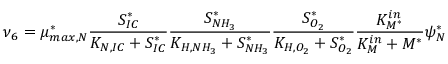Convert formula to latex. <formula><loc_0><loc_0><loc_500><loc_500>\nu _ { 6 } = \mu _ { \max , N } ^ { * } \frac { S _ { I C } ^ { * } } { K _ { N , I C } + S _ { I C } ^ { * } } \frac { S _ { N H _ { 3 } } ^ { * } } { K _ { H , N H _ { 3 } } + S _ { N H _ { 3 } } ^ { * } } \frac { S _ { O _ { 2 } } ^ { * } } { K _ { H , O _ { 2 } } + S _ { O _ { 2 } } ^ { * } } \frac { K _ { M ^ { * } } ^ { i n } } { K _ { M } ^ { i n } + M ^ { * } } \psi _ { N } ^ { * }</formula> 